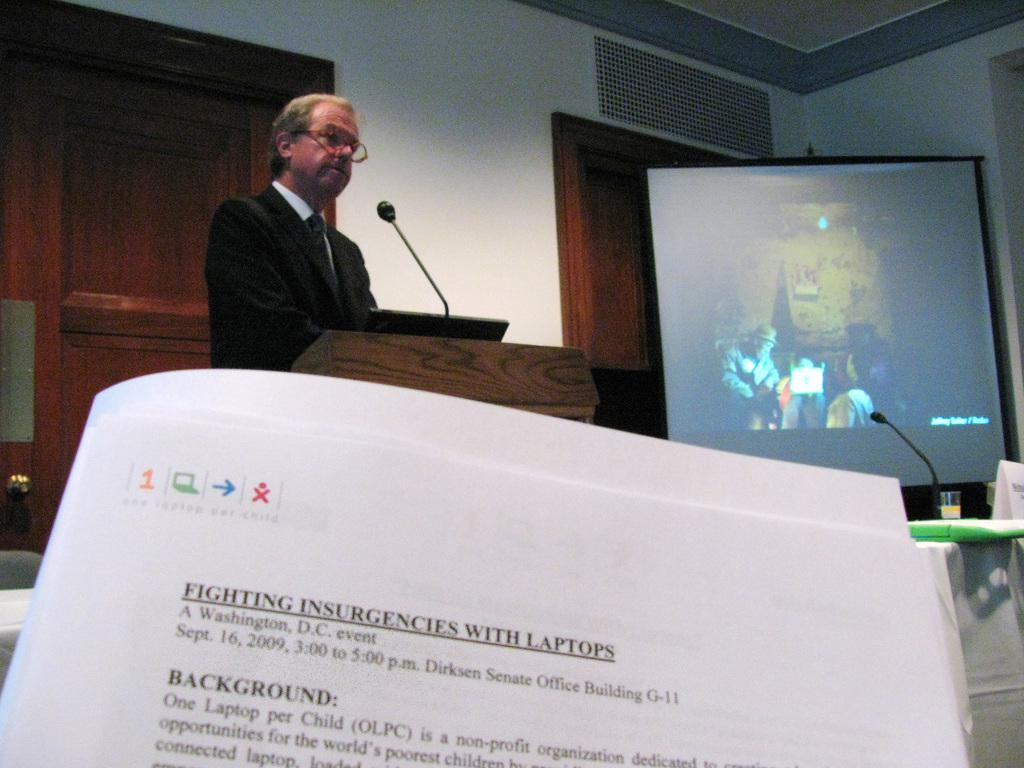<image>
Create a compact narrative representing the image presented. A Washington D.C. event was scheduled for Sept. 16, 2009 at 3:00-5:00 p.m. 